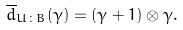<formula> <loc_0><loc_0><loc_500><loc_500>\overline { d } _ { U \colon B } ( \gamma ) = ( \gamma + 1 ) \otimes \gamma .</formula> 